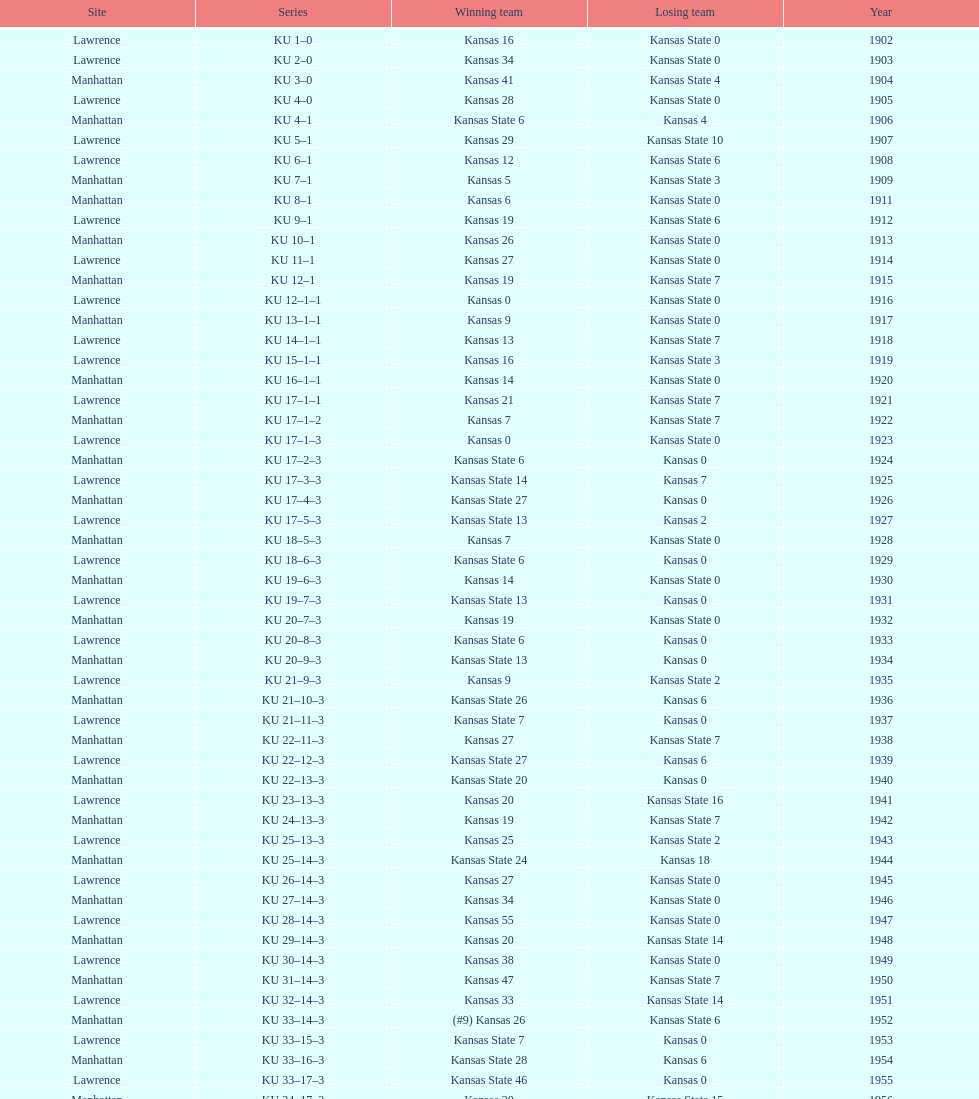Before 1950 what was the most points kansas scored? 55. 